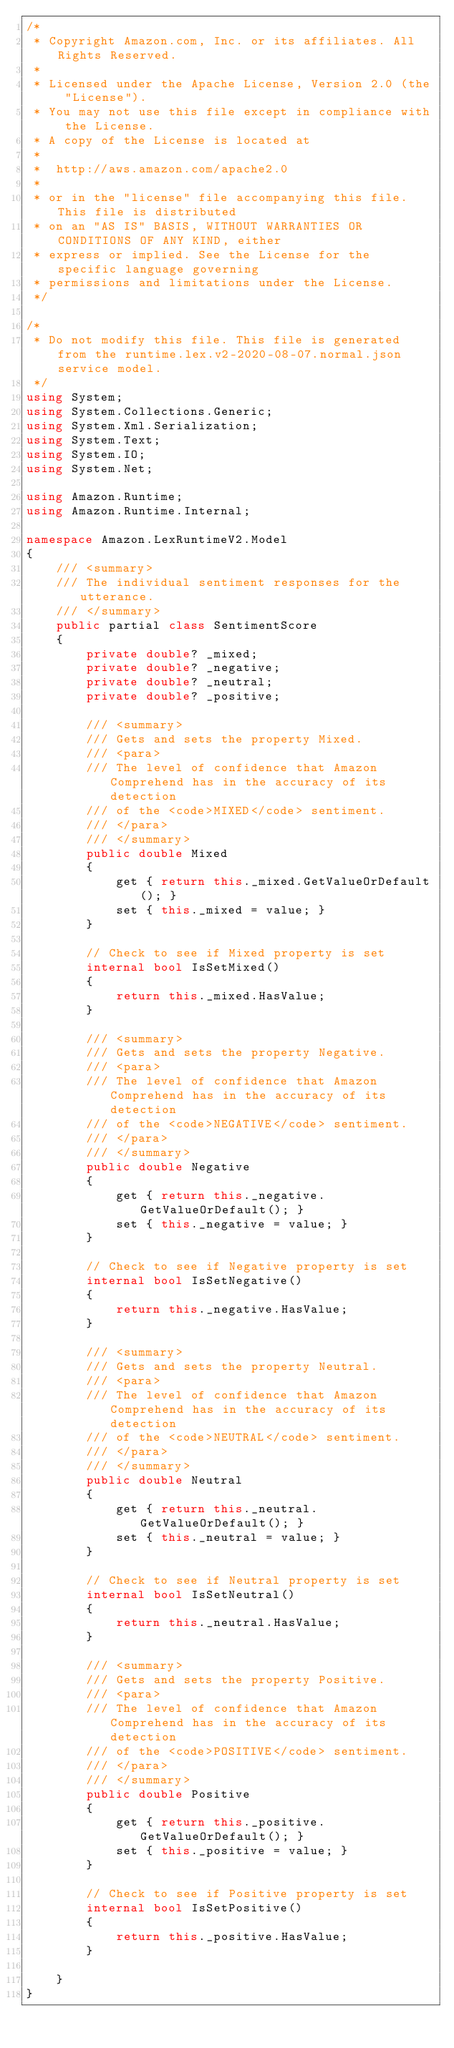Convert code to text. <code><loc_0><loc_0><loc_500><loc_500><_C#_>/*
 * Copyright Amazon.com, Inc. or its affiliates. All Rights Reserved.
 * 
 * Licensed under the Apache License, Version 2.0 (the "License").
 * You may not use this file except in compliance with the License.
 * A copy of the License is located at
 * 
 *  http://aws.amazon.com/apache2.0
 * 
 * or in the "license" file accompanying this file. This file is distributed
 * on an "AS IS" BASIS, WITHOUT WARRANTIES OR CONDITIONS OF ANY KIND, either
 * express or implied. See the License for the specific language governing
 * permissions and limitations under the License.
 */

/*
 * Do not modify this file. This file is generated from the runtime.lex.v2-2020-08-07.normal.json service model.
 */
using System;
using System.Collections.Generic;
using System.Xml.Serialization;
using System.Text;
using System.IO;
using System.Net;

using Amazon.Runtime;
using Amazon.Runtime.Internal;

namespace Amazon.LexRuntimeV2.Model
{
    /// <summary>
    /// The individual sentiment responses for the utterance.
    /// </summary>
    public partial class SentimentScore
    {
        private double? _mixed;
        private double? _negative;
        private double? _neutral;
        private double? _positive;

        /// <summary>
        /// Gets and sets the property Mixed. 
        /// <para>
        /// The level of confidence that Amazon Comprehend has in the accuracy of its detection
        /// of the <code>MIXED</code> sentiment.
        /// </para>
        /// </summary>
        public double Mixed
        {
            get { return this._mixed.GetValueOrDefault(); }
            set { this._mixed = value; }
        }

        // Check to see if Mixed property is set
        internal bool IsSetMixed()
        {
            return this._mixed.HasValue; 
        }

        /// <summary>
        /// Gets and sets the property Negative. 
        /// <para>
        /// The level of confidence that Amazon Comprehend has in the accuracy of its detection
        /// of the <code>NEGATIVE</code> sentiment.
        /// </para>
        /// </summary>
        public double Negative
        {
            get { return this._negative.GetValueOrDefault(); }
            set { this._negative = value; }
        }

        // Check to see if Negative property is set
        internal bool IsSetNegative()
        {
            return this._negative.HasValue; 
        }

        /// <summary>
        /// Gets and sets the property Neutral. 
        /// <para>
        /// The level of confidence that Amazon Comprehend has in the accuracy of its detection
        /// of the <code>NEUTRAL</code> sentiment.
        /// </para>
        /// </summary>
        public double Neutral
        {
            get { return this._neutral.GetValueOrDefault(); }
            set { this._neutral = value; }
        }

        // Check to see if Neutral property is set
        internal bool IsSetNeutral()
        {
            return this._neutral.HasValue; 
        }

        /// <summary>
        /// Gets and sets the property Positive. 
        /// <para>
        /// The level of confidence that Amazon Comprehend has in the accuracy of its detection
        /// of the <code>POSITIVE</code> sentiment.
        /// </para>
        /// </summary>
        public double Positive
        {
            get { return this._positive.GetValueOrDefault(); }
            set { this._positive = value; }
        }

        // Check to see if Positive property is set
        internal bool IsSetPositive()
        {
            return this._positive.HasValue; 
        }

    }
}</code> 